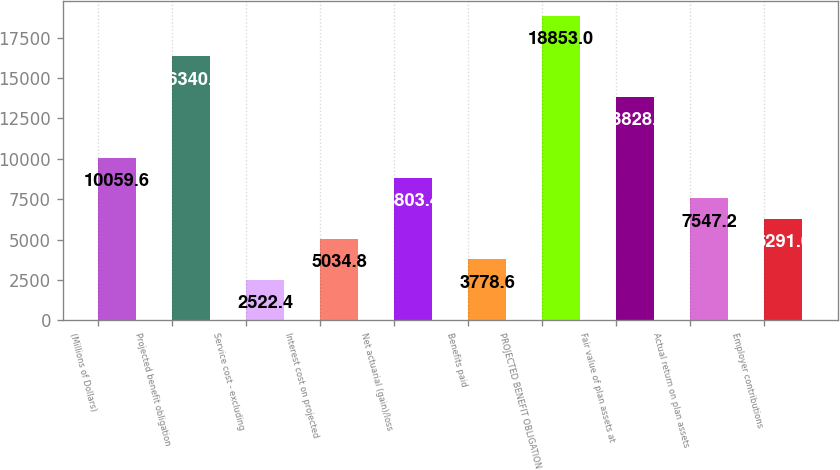Convert chart. <chart><loc_0><loc_0><loc_500><loc_500><bar_chart><fcel>(Millions of Dollars)<fcel>Projected benefit obligation<fcel>Service cost - excluding<fcel>Interest cost on projected<fcel>Net actuarial (gain)/loss<fcel>Benefits paid<fcel>PROJECTED BENEFIT OBLIGATION<fcel>Fair value of plan assets at<fcel>Actual return on plan assets<fcel>Employer contributions<nl><fcel>10059.6<fcel>16340.6<fcel>2522.4<fcel>5034.8<fcel>8803.4<fcel>3778.6<fcel>18853<fcel>13828.2<fcel>7547.2<fcel>6291<nl></chart> 